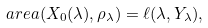<formula> <loc_0><loc_0><loc_500><loc_500>\ a r e a ( X _ { 0 } ( \lambda ) , \rho _ { \lambda } ) = \ell ( \lambda , Y _ { \lambda } ) ,</formula> 